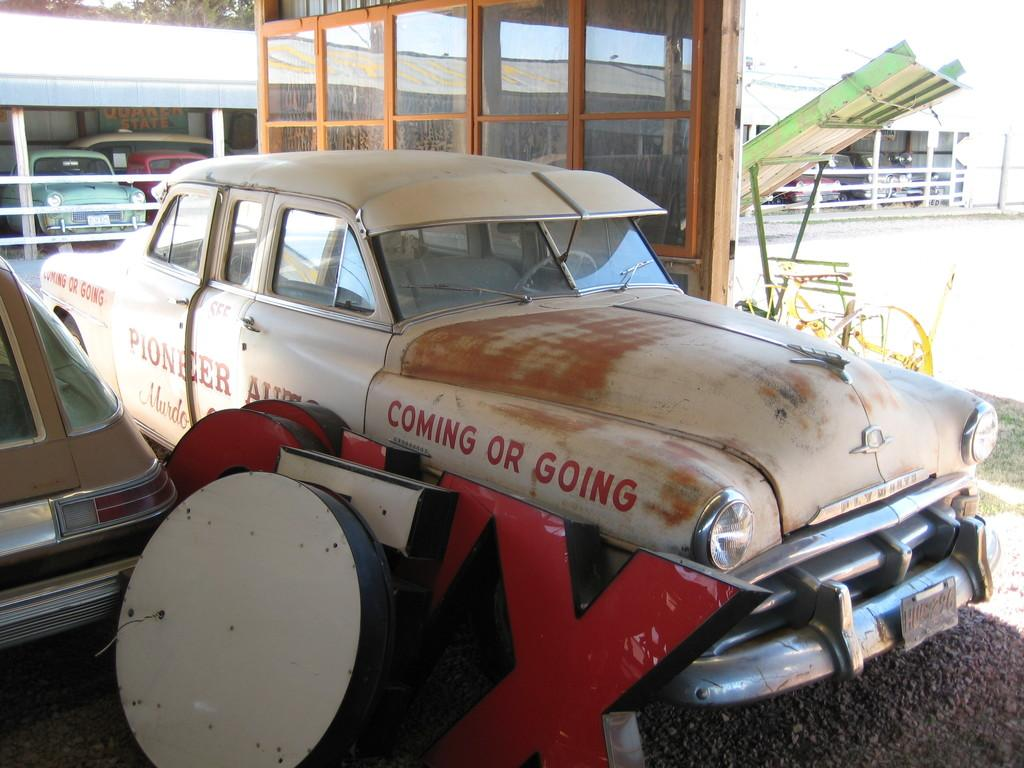<image>
Render a clear and concise summary of the photo. the old car in the garage says coming or going on the front 